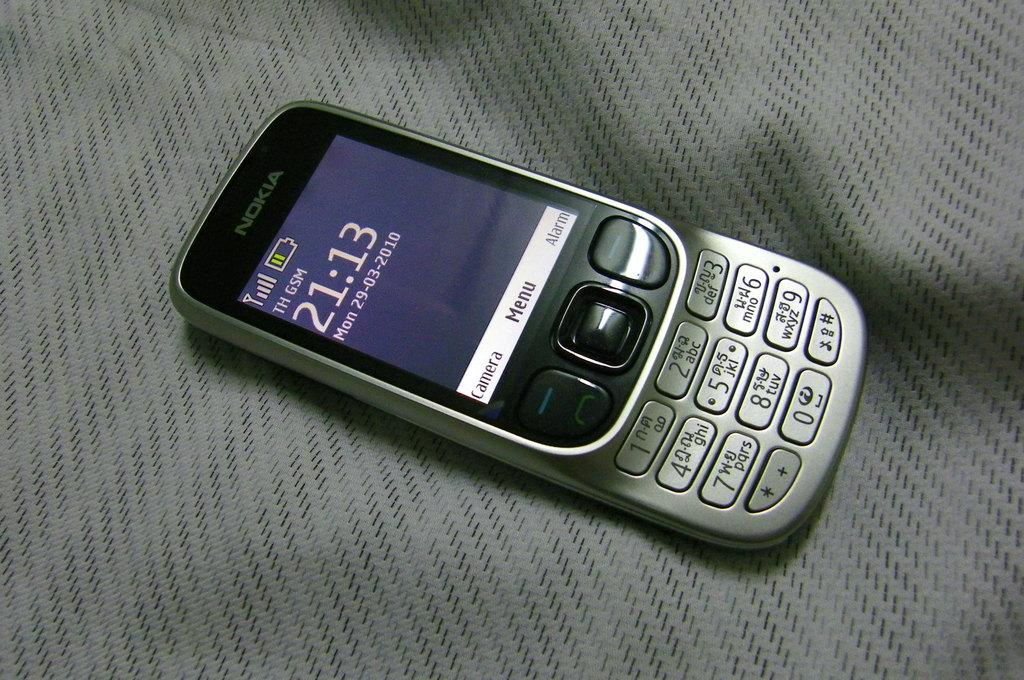<image>
Relay a brief, clear account of the picture shown. A Nokia cell phone that says 21:13 on the display and shows low battery. 